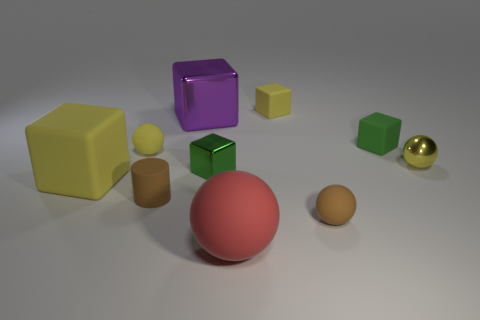Subtract all tiny shiny spheres. How many spheres are left? 3 Subtract all yellow balls. How many balls are left? 2 Subtract all purple cubes. How many yellow spheres are left? 2 Subtract all spheres. How many objects are left? 6 Subtract all small yellow cubes. Subtract all metal things. How many objects are left? 6 Add 6 small green matte things. How many small green matte things are left? 7 Add 5 tiny green shiny things. How many tiny green shiny things exist? 6 Subtract 1 brown balls. How many objects are left? 9 Subtract 3 cubes. How many cubes are left? 2 Subtract all purple blocks. Subtract all purple cylinders. How many blocks are left? 4 